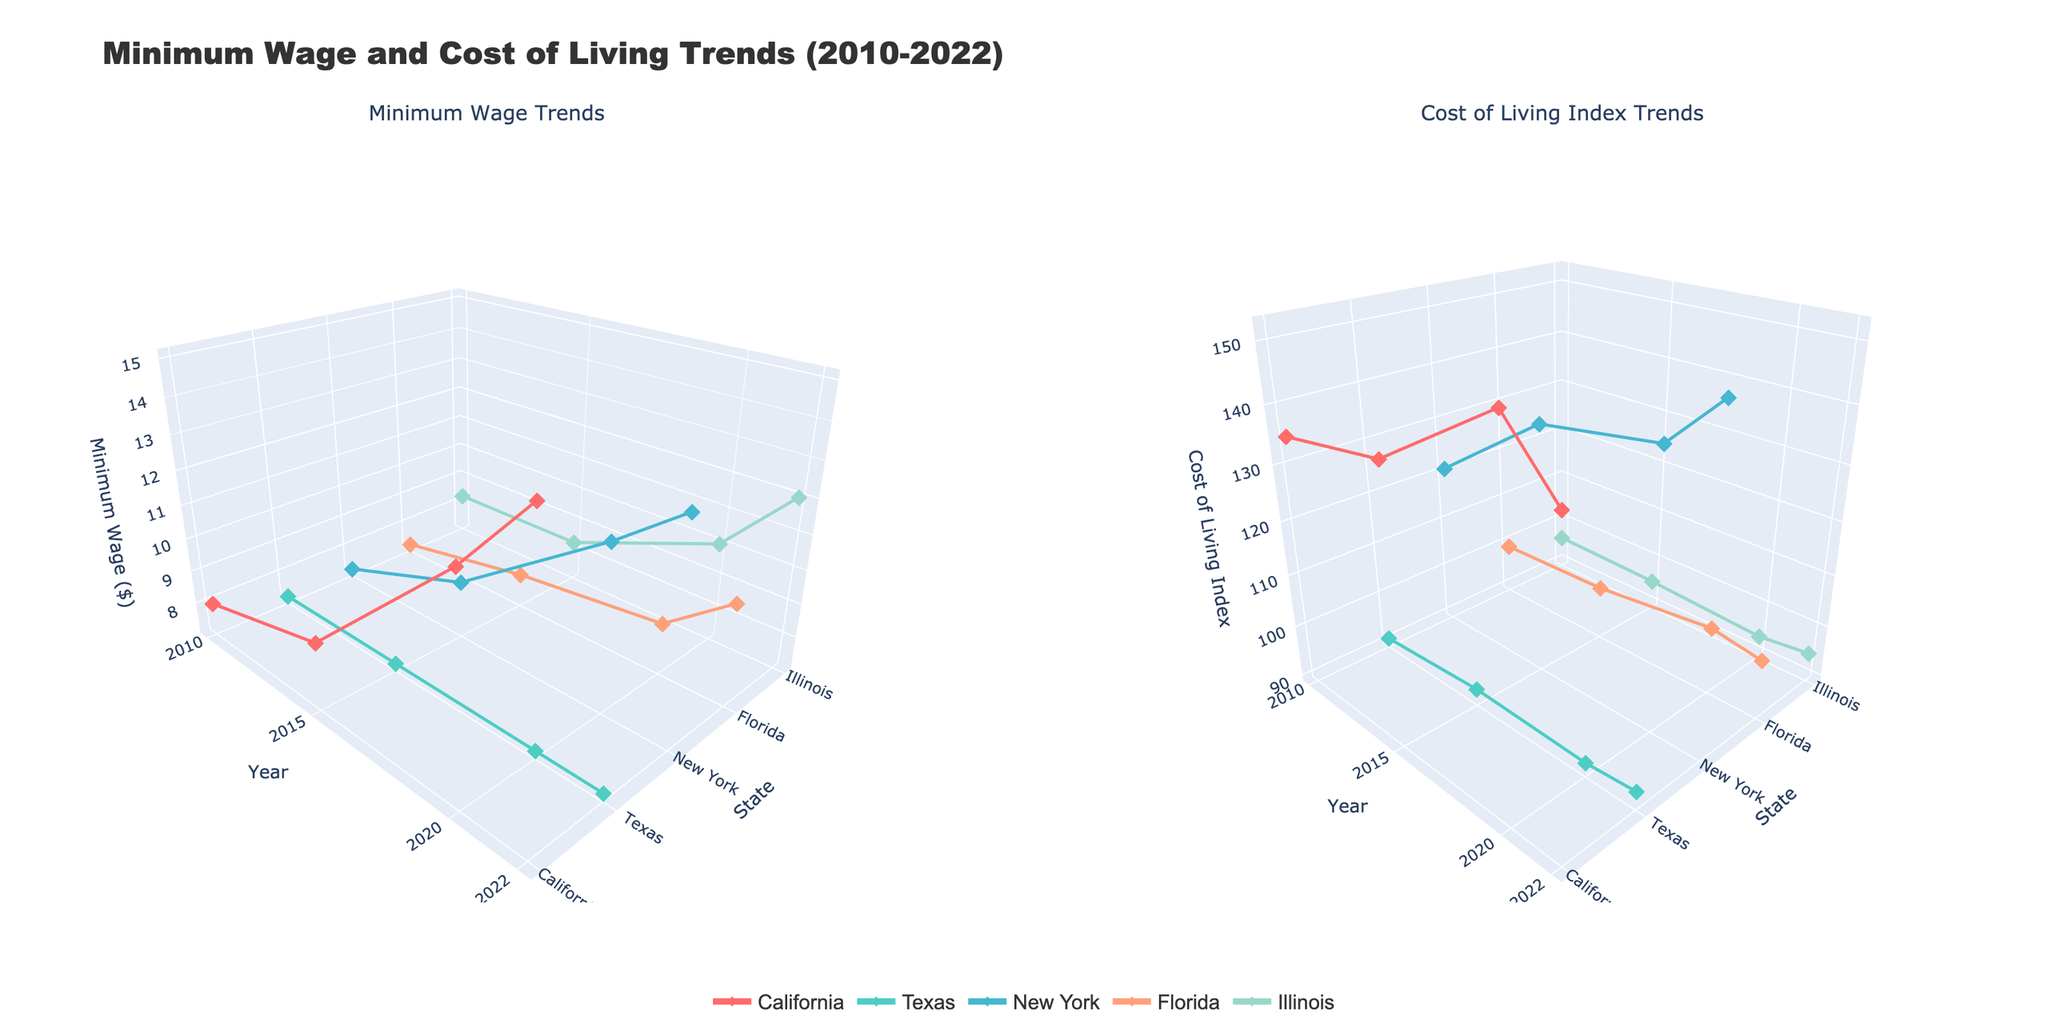What's the title of the figure? The title is prominently displayed at the top of the figure, typically in a larger and bold font, indicating the main subject of the visualization.
Answer: Minimum Wage and Cost of Living Trends (2010-2022) What states are represented in the 3D plots? States are represented along the y-axis of the 3D plots, each having their own series of data points connected by lines or markers. You can see the state names such as California, Texas, New York, Florida, and Illinois.
Answer: California, Texas, New York, Florida, Illinois In which year did California have the highest minimum wage? Examine the data points for California in the "Minimum Wage Trends" subplot. The point at the highest position on the z-axis for California indicates the year.
Answer: 2022 How does the Cost of Living Index for Texas in 2022 compare with that in 2010? In the "Cost of Living Index Trends" subplot, locate the data points for Texas in both 2010 and 2022. Compare the positions along the z-axis to ascertain if there's an increase or decrease.
Answer: It increased from 90.7 to 92.3 Which state saw the most significant increase in minimum wage from 2010 to 2022? For each state, identify the data points for 2010 and 2022 in the "Minimum Wage Trends" subplot. Measure the difference in z-axis values to find out the state with the highest increase.
Answer: California Did any state have a constant minimum wage across the years? Inspect the "Minimum Wage Trends" subplot and check if any state's data points form a perfectly horizontal line, indicating no change over the years.
Answer: Texas Among the five states represented, which one had the highest Cost of Living Index in 2022? In the "Cost of Living Index Trends" subplot, focus on the 2022 data points and compare the z-axis values for all states. The highest value indicates the state.
Answer: New York On which subplot, the “Minimum Wage Trends” or the “Cost of Living Index Trends”, do you see more variation in the z-axis across the years for all states? By examining the overall spread and fluctuation in the z-axis across both subplots, determine where the lines and markers show more changes across the years.
Answer: Minimum Wage Trends 